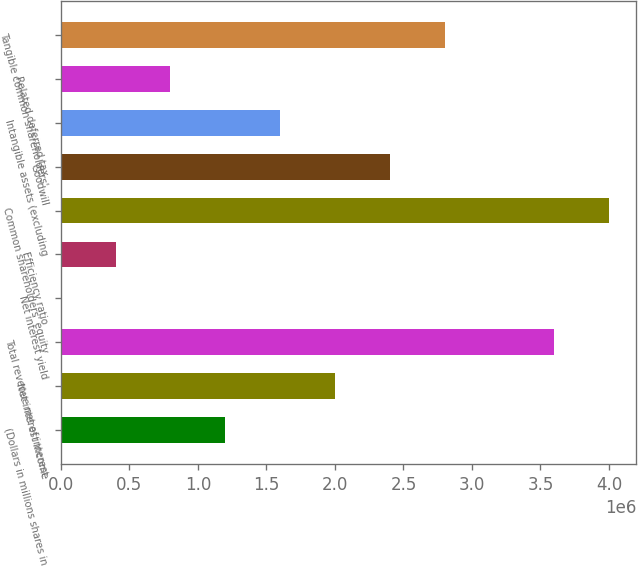<chart> <loc_0><loc_0><loc_500><loc_500><bar_chart><fcel>(Dollars in millions shares in<fcel>Net interest income<fcel>Total revenue net of interest<fcel>Net interest yield<fcel>Efficiency ratio<fcel>Common shareholders' equity<fcel>Goodwill<fcel>Intangible assets (excluding<fcel>Related deferred tax<fcel>Tangible common shareholders'<nl><fcel>1.19991e+06<fcel>1.99985e+06<fcel>3.59972e+06<fcel>2.84<fcel>399971<fcel>3.99969e+06<fcel>2.39981e+06<fcel>1.59988e+06<fcel>799940<fcel>2.79978e+06<nl></chart> 